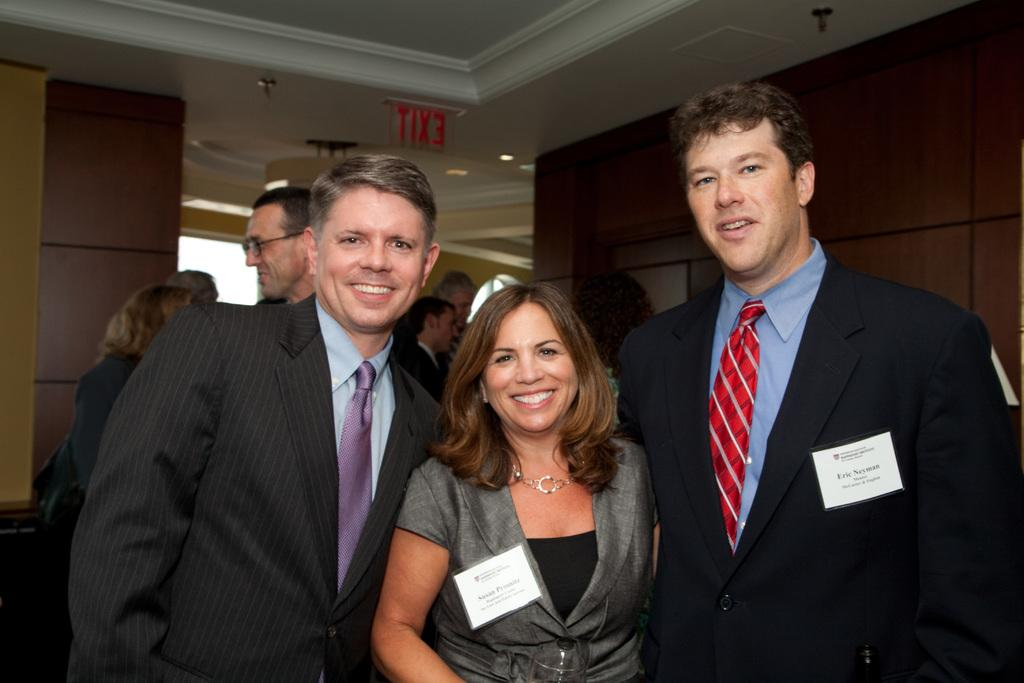How many people are standing together in the center of the image? There are three persons standing in the center of the image. What can be seen in the background of the image? There is a wall, a light, a signboard, and a group of people in the background of the image. What day of the week is it according to the signboard in the image? There is no information about the day of the week on the signboard in the image. Can you see any icicles hanging from the wall in the image? There are no icicles visible in the image. 